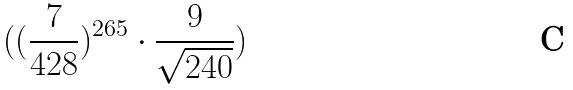Convert formula to latex. <formula><loc_0><loc_0><loc_500><loc_500>( ( \frac { 7 } { 4 2 8 } ) ^ { 2 6 5 } \cdot \frac { 9 } { \sqrt { 2 4 0 } } )</formula> 